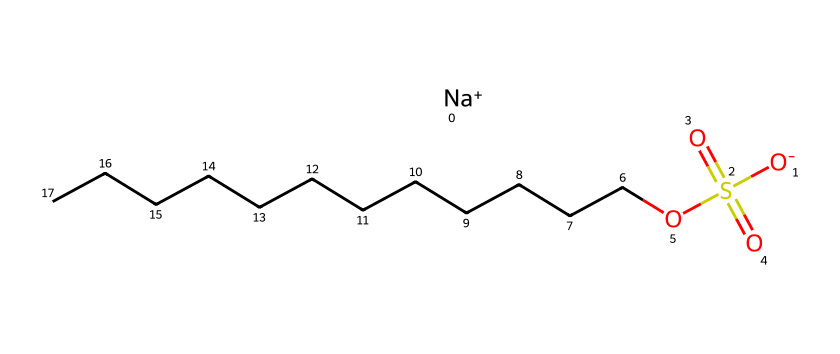What is the chemical name of this surfactant? The chemical structure includes "sodium" as the cation and "dodecyl sulfate" derived from the sulfate ester, indicating the full name is sodium dodecyl sulfate.
Answer: sodium dodecyl sulfate How many carbon atoms are present in this structure? In the carbon chain denoted by CCCCCCCCCCCC, there are 12 carbon atoms present in total.
Answer: 12 What type of functional group is represented by the -SO4 part of the structure? The -SO4 section of the structure indicates the presence of a sulfate functional group, which is characteristic for surfactants to provide polar properties.
Answer: sulfate How many oxygen atoms are in the sulfate group? The sulfate group -SO4 contains four oxygen atoms connected to the sulfur atom in the center of that functional group.
Answer: 4 What is the charge on the sodium ion in this structure? The sodium ion is indicated by [Na+], which shows that it has a +1 charge.
Answer: +1 Which part of this molecule primarily contributes to its hydrophilic nature? The sulfate group -SO4 is polar and is responsible for the hydrophilic nature of sodium dodecyl sulfate, allowing it to interact with water.
Answer: sulfate group What kind of surfactant is sodium dodecyl sulfate classified as? Sodium dodecyl sulfate is classified as an anionic surfactant due to the presence of the negatively charged sulfate group.
Answer: anionic 